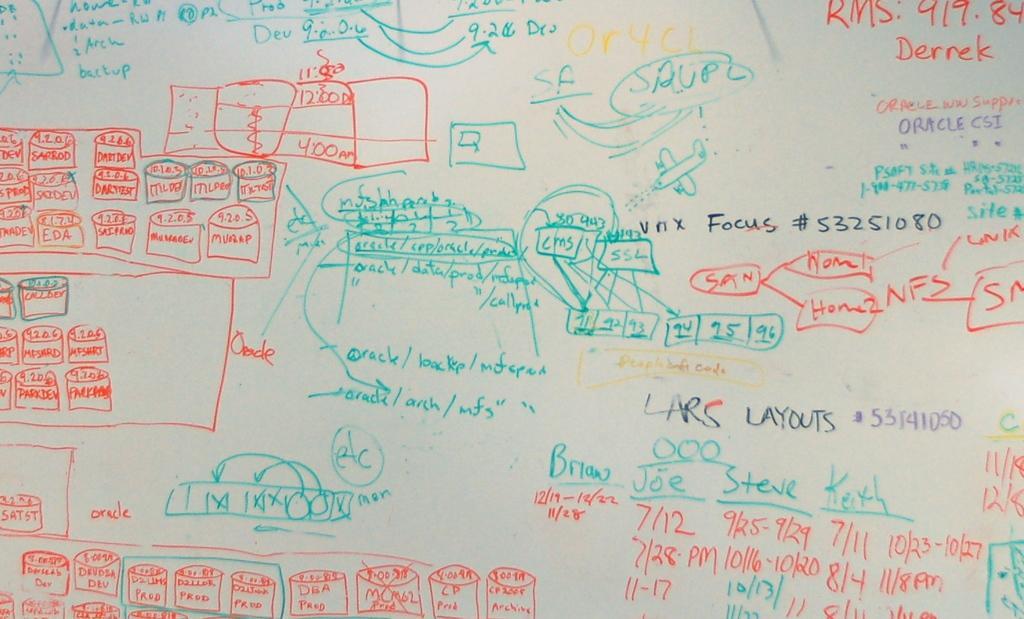In one or two sentences, can you explain what this image depicts? In this image, we can see text on the board. 